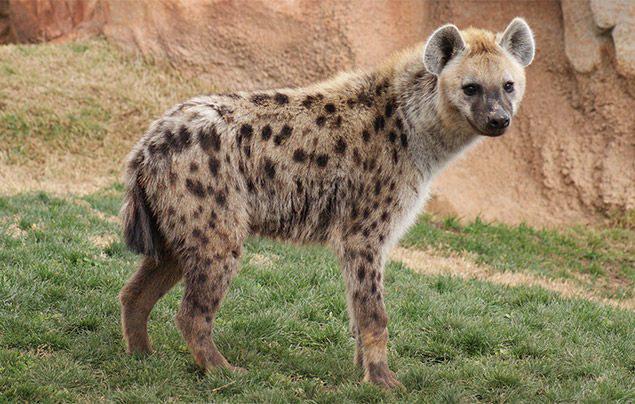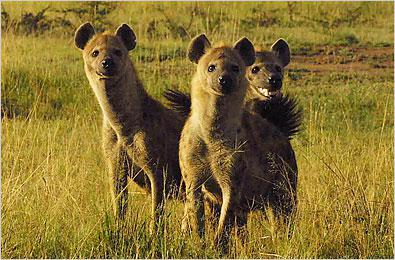The first image is the image on the left, the second image is the image on the right. For the images displayed, is the sentence "The image on the left has one hyena that is facing towards the right." factually correct? Answer yes or no. Yes. The first image is the image on the left, the second image is the image on the right. Considering the images on both sides, is "There are at most 4 hyenas." valid? Answer yes or no. Yes. 